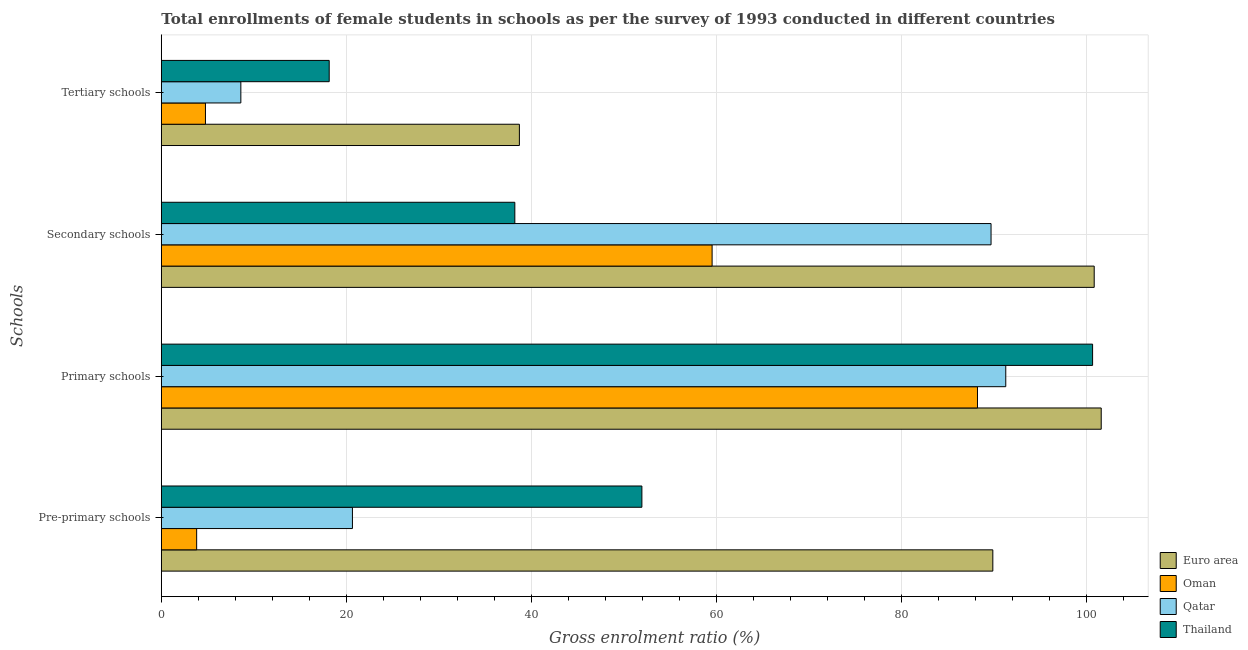Are the number of bars on each tick of the Y-axis equal?
Offer a very short reply. Yes. How many bars are there on the 4th tick from the bottom?
Your answer should be very brief. 4. What is the label of the 4th group of bars from the top?
Make the answer very short. Pre-primary schools. What is the gross enrolment ratio(female) in secondary schools in Oman?
Offer a very short reply. 59.52. Across all countries, what is the maximum gross enrolment ratio(female) in tertiary schools?
Offer a terse response. 38.7. Across all countries, what is the minimum gross enrolment ratio(female) in primary schools?
Your response must be concise. 88.2. In which country was the gross enrolment ratio(female) in pre-primary schools minimum?
Ensure brevity in your answer.  Oman. What is the total gross enrolment ratio(female) in secondary schools in the graph?
Make the answer very short. 288.21. What is the difference between the gross enrolment ratio(female) in tertiary schools in Euro area and that in Oman?
Your response must be concise. 33.93. What is the difference between the gross enrolment ratio(female) in tertiary schools in Thailand and the gross enrolment ratio(female) in secondary schools in Qatar?
Give a very brief answer. -71.52. What is the average gross enrolment ratio(female) in pre-primary schools per country?
Provide a short and direct response. 41.57. What is the difference between the gross enrolment ratio(female) in pre-primary schools and gross enrolment ratio(female) in primary schools in Oman?
Your response must be concise. -84.38. In how many countries, is the gross enrolment ratio(female) in primary schools greater than 76 %?
Offer a terse response. 4. What is the ratio of the gross enrolment ratio(female) in primary schools in Euro area to that in Oman?
Your answer should be compact. 1.15. What is the difference between the highest and the second highest gross enrolment ratio(female) in pre-primary schools?
Make the answer very short. 37.92. What is the difference between the highest and the lowest gross enrolment ratio(female) in secondary schools?
Make the answer very short. 62.61. Is the sum of the gross enrolment ratio(female) in secondary schools in Oman and Euro area greater than the maximum gross enrolment ratio(female) in primary schools across all countries?
Make the answer very short. Yes. Is it the case that in every country, the sum of the gross enrolment ratio(female) in primary schools and gross enrolment ratio(female) in pre-primary schools is greater than the sum of gross enrolment ratio(female) in secondary schools and gross enrolment ratio(female) in tertiary schools?
Provide a succinct answer. No. What does the 2nd bar from the top in Pre-primary schools represents?
Make the answer very short. Qatar. What does the 2nd bar from the bottom in Primary schools represents?
Provide a succinct answer. Oman. Is it the case that in every country, the sum of the gross enrolment ratio(female) in pre-primary schools and gross enrolment ratio(female) in primary schools is greater than the gross enrolment ratio(female) in secondary schools?
Make the answer very short. Yes. Are all the bars in the graph horizontal?
Your answer should be compact. Yes. What is the difference between two consecutive major ticks on the X-axis?
Ensure brevity in your answer.  20. Are the values on the major ticks of X-axis written in scientific E-notation?
Give a very brief answer. No. Where does the legend appear in the graph?
Provide a succinct answer. Bottom right. What is the title of the graph?
Your response must be concise. Total enrollments of female students in schools as per the survey of 1993 conducted in different countries. What is the label or title of the X-axis?
Your response must be concise. Gross enrolment ratio (%). What is the label or title of the Y-axis?
Offer a very short reply. Schools. What is the Gross enrolment ratio (%) in Euro area in Pre-primary schools?
Keep it short and to the point. 89.86. What is the Gross enrolment ratio (%) of Oman in Pre-primary schools?
Your answer should be very brief. 3.82. What is the Gross enrolment ratio (%) of Qatar in Pre-primary schools?
Your answer should be very brief. 20.65. What is the Gross enrolment ratio (%) of Thailand in Pre-primary schools?
Make the answer very short. 51.93. What is the Gross enrolment ratio (%) of Euro area in Primary schools?
Offer a very short reply. 101.57. What is the Gross enrolment ratio (%) of Oman in Primary schools?
Ensure brevity in your answer.  88.2. What is the Gross enrolment ratio (%) in Qatar in Primary schools?
Offer a terse response. 91.26. What is the Gross enrolment ratio (%) of Thailand in Primary schools?
Offer a very short reply. 100.64. What is the Gross enrolment ratio (%) of Euro area in Secondary schools?
Your answer should be very brief. 100.81. What is the Gross enrolment ratio (%) in Oman in Secondary schools?
Your answer should be compact. 59.52. What is the Gross enrolment ratio (%) in Qatar in Secondary schools?
Keep it short and to the point. 89.67. What is the Gross enrolment ratio (%) of Thailand in Secondary schools?
Your answer should be very brief. 38.2. What is the Gross enrolment ratio (%) of Euro area in Tertiary schools?
Keep it short and to the point. 38.7. What is the Gross enrolment ratio (%) in Oman in Tertiary schools?
Keep it short and to the point. 4.77. What is the Gross enrolment ratio (%) of Qatar in Tertiary schools?
Your answer should be very brief. 8.59. What is the Gross enrolment ratio (%) of Thailand in Tertiary schools?
Your answer should be compact. 18.14. Across all Schools, what is the maximum Gross enrolment ratio (%) of Euro area?
Your answer should be very brief. 101.57. Across all Schools, what is the maximum Gross enrolment ratio (%) in Oman?
Your answer should be very brief. 88.2. Across all Schools, what is the maximum Gross enrolment ratio (%) of Qatar?
Offer a very short reply. 91.26. Across all Schools, what is the maximum Gross enrolment ratio (%) in Thailand?
Keep it short and to the point. 100.64. Across all Schools, what is the minimum Gross enrolment ratio (%) of Euro area?
Your answer should be compact. 38.7. Across all Schools, what is the minimum Gross enrolment ratio (%) in Oman?
Make the answer very short. 3.82. Across all Schools, what is the minimum Gross enrolment ratio (%) in Qatar?
Your answer should be very brief. 8.59. Across all Schools, what is the minimum Gross enrolment ratio (%) in Thailand?
Keep it short and to the point. 18.14. What is the total Gross enrolment ratio (%) of Euro area in the graph?
Your answer should be compact. 330.94. What is the total Gross enrolment ratio (%) in Oman in the graph?
Provide a succinct answer. 156.31. What is the total Gross enrolment ratio (%) in Qatar in the graph?
Your answer should be very brief. 210.17. What is the total Gross enrolment ratio (%) of Thailand in the graph?
Provide a succinct answer. 208.92. What is the difference between the Gross enrolment ratio (%) of Euro area in Pre-primary schools and that in Primary schools?
Your response must be concise. -11.71. What is the difference between the Gross enrolment ratio (%) of Oman in Pre-primary schools and that in Primary schools?
Your answer should be very brief. -84.38. What is the difference between the Gross enrolment ratio (%) of Qatar in Pre-primary schools and that in Primary schools?
Your answer should be compact. -70.6. What is the difference between the Gross enrolment ratio (%) of Thailand in Pre-primary schools and that in Primary schools?
Offer a terse response. -48.71. What is the difference between the Gross enrolment ratio (%) in Euro area in Pre-primary schools and that in Secondary schools?
Your response must be concise. -10.96. What is the difference between the Gross enrolment ratio (%) in Oman in Pre-primary schools and that in Secondary schools?
Offer a very short reply. -55.7. What is the difference between the Gross enrolment ratio (%) in Qatar in Pre-primary schools and that in Secondary schools?
Give a very brief answer. -69.01. What is the difference between the Gross enrolment ratio (%) in Thailand in Pre-primary schools and that in Secondary schools?
Offer a terse response. 13.73. What is the difference between the Gross enrolment ratio (%) in Euro area in Pre-primary schools and that in Tertiary schools?
Provide a succinct answer. 51.16. What is the difference between the Gross enrolment ratio (%) of Oman in Pre-primary schools and that in Tertiary schools?
Keep it short and to the point. -0.95. What is the difference between the Gross enrolment ratio (%) of Qatar in Pre-primary schools and that in Tertiary schools?
Your answer should be compact. 12.06. What is the difference between the Gross enrolment ratio (%) in Thailand in Pre-primary schools and that in Tertiary schools?
Ensure brevity in your answer.  33.79. What is the difference between the Gross enrolment ratio (%) in Euro area in Primary schools and that in Secondary schools?
Your answer should be compact. 0.76. What is the difference between the Gross enrolment ratio (%) of Oman in Primary schools and that in Secondary schools?
Offer a terse response. 28.68. What is the difference between the Gross enrolment ratio (%) of Qatar in Primary schools and that in Secondary schools?
Keep it short and to the point. 1.59. What is the difference between the Gross enrolment ratio (%) in Thailand in Primary schools and that in Secondary schools?
Offer a very short reply. 62.44. What is the difference between the Gross enrolment ratio (%) of Euro area in Primary schools and that in Tertiary schools?
Ensure brevity in your answer.  62.88. What is the difference between the Gross enrolment ratio (%) of Oman in Primary schools and that in Tertiary schools?
Your response must be concise. 83.43. What is the difference between the Gross enrolment ratio (%) of Qatar in Primary schools and that in Tertiary schools?
Your answer should be compact. 82.66. What is the difference between the Gross enrolment ratio (%) of Thailand in Primary schools and that in Tertiary schools?
Keep it short and to the point. 82.5. What is the difference between the Gross enrolment ratio (%) of Euro area in Secondary schools and that in Tertiary schools?
Give a very brief answer. 62.12. What is the difference between the Gross enrolment ratio (%) in Oman in Secondary schools and that in Tertiary schools?
Your response must be concise. 54.75. What is the difference between the Gross enrolment ratio (%) of Qatar in Secondary schools and that in Tertiary schools?
Make the answer very short. 81.07. What is the difference between the Gross enrolment ratio (%) of Thailand in Secondary schools and that in Tertiary schools?
Keep it short and to the point. 20.06. What is the difference between the Gross enrolment ratio (%) of Euro area in Pre-primary schools and the Gross enrolment ratio (%) of Oman in Primary schools?
Your response must be concise. 1.66. What is the difference between the Gross enrolment ratio (%) of Euro area in Pre-primary schools and the Gross enrolment ratio (%) of Qatar in Primary schools?
Make the answer very short. -1.4. What is the difference between the Gross enrolment ratio (%) in Euro area in Pre-primary schools and the Gross enrolment ratio (%) in Thailand in Primary schools?
Give a very brief answer. -10.78. What is the difference between the Gross enrolment ratio (%) in Oman in Pre-primary schools and the Gross enrolment ratio (%) in Qatar in Primary schools?
Your answer should be compact. -87.44. What is the difference between the Gross enrolment ratio (%) of Oman in Pre-primary schools and the Gross enrolment ratio (%) of Thailand in Primary schools?
Your answer should be compact. -96.82. What is the difference between the Gross enrolment ratio (%) in Qatar in Pre-primary schools and the Gross enrolment ratio (%) in Thailand in Primary schools?
Provide a short and direct response. -79.99. What is the difference between the Gross enrolment ratio (%) of Euro area in Pre-primary schools and the Gross enrolment ratio (%) of Oman in Secondary schools?
Offer a very short reply. 30.34. What is the difference between the Gross enrolment ratio (%) of Euro area in Pre-primary schools and the Gross enrolment ratio (%) of Qatar in Secondary schools?
Keep it short and to the point. 0.19. What is the difference between the Gross enrolment ratio (%) of Euro area in Pre-primary schools and the Gross enrolment ratio (%) of Thailand in Secondary schools?
Keep it short and to the point. 51.66. What is the difference between the Gross enrolment ratio (%) in Oman in Pre-primary schools and the Gross enrolment ratio (%) in Qatar in Secondary schools?
Provide a short and direct response. -85.85. What is the difference between the Gross enrolment ratio (%) of Oman in Pre-primary schools and the Gross enrolment ratio (%) of Thailand in Secondary schools?
Keep it short and to the point. -34.38. What is the difference between the Gross enrolment ratio (%) in Qatar in Pre-primary schools and the Gross enrolment ratio (%) in Thailand in Secondary schools?
Give a very brief answer. -17.55. What is the difference between the Gross enrolment ratio (%) in Euro area in Pre-primary schools and the Gross enrolment ratio (%) in Oman in Tertiary schools?
Provide a short and direct response. 85.09. What is the difference between the Gross enrolment ratio (%) of Euro area in Pre-primary schools and the Gross enrolment ratio (%) of Qatar in Tertiary schools?
Provide a short and direct response. 81.26. What is the difference between the Gross enrolment ratio (%) in Euro area in Pre-primary schools and the Gross enrolment ratio (%) in Thailand in Tertiary schools?
Your response must be concise. 71.71. What is the difference between the Gross enrolment ratio (%) in Oman in Pre-primary schools and the Gross enrolment ratio (%) in Qatar in Tertiary schools?
Offer a very short reply. -4.77. What is the difference between the Gross enrolment ratio (%) in Oman in Pre-primary schools and the Gross enrolment ratio (%) in Thailand in Tertiary schools?
Your response must be concise. -14.32. What is the difference between the Gross enrolment ratio (%) of Qatar in Pre-primary schools and the Gross enrolment ratio (%) of Thailand in Tertiary schools?
Make the answer very short. 2.51. What is the difference between the Gross enrolment ratio (%) of Euro area in Primary schools and the Gross enrolment ratio (%) of Oman in Secondary schools?
Your answer should be very brief. 42.05. What is the difference between the Gross enrolment ratio (%) of Euro area in Primary schools and the Gross enrolment ratio (%) of Qatar in Secondary schools?
Provide a succinct answer. 11.91. What is the difference between the Gross enrolment ratio (%) in Euro area in Primary schools and the Gross enrolment ratio (%) in Thailand in Secondary schools?
Offer a very short reply. 63.37. What is the difference between the Gross enrolment ratio (%) of Oman in Primary schools and the Gross enrolment ratio (%) of Qatar in Secondary schools?
Give a very brief answer. -1.46. What is the difference between the Gross enrolment ratio (%) in Oman in Primary schools and the Gross enrolment ratio (%) in Thailand in Secondary schools?
Offer a terse response. 50. What is the difference between the Gross enrolment ratio (%) of Qatar in Primary schools and the Gross enrolment ratio (%) of Thailand in Secondary schools?
Offer a terse response. 53.05. What is the difference between the Gross enrolment ratio (%) in Euro area in Primary schools and the Gross enrolment ratio (%) in Oman in Tertiary schools?
Give a very brief answer. 96.8. What is the difference between the Gross enrolment ratio (%) of Euro area in Primary schools and the Gross enrolment ratio (%) of Qatar in Tertiary schools?
Offer a terse response. 92.98. What is the difference between the Gross enrolment ratio (%) of Euro area in Primary schools and the Gross enrolment ratio (%) of Thailand in Tertiary schools?
Ensure brevity in your answer.  83.43. What is the difference between the Gross enrolment ratio (%) of Oman in Primary schools and the Gross enrolment ratio (%) of Qatar in Tertiary schools?
Provide a succinct answer. 79.61. What is the difference between the Gross enrolment ratio (%) in Oman in Primary schools and the Gross enrolment ratio (%) in Thailand in Tertiary schools?
Your response must be concise. 70.06. What is the difference between the Gross enrolment ratio (%) of Qatar in Primary schools and the Gross enrolment ratio (%) of Thailand in Tertiary schools?
Provide a short and direct response. 73.11. What is the difference between the Gross enrolment ratio (%) in Euro area in Secondary schools and the Gross enrolment ratio (%) in Oman in Tertiary schools?
Offer a terse response. 96.05. What is the difference between the Gross enrolment ratio (%) of Euro area in Secondary schools and the Gross enrolment ratio (%) of Qatar in Tertiary schools?
Provide a short and direct response. 92.22. What is the difference between the Gross enrolment ratio (%) in Euro area in Secondary schools and the Gross enrolment ratio (%) in Thailand in Tertiary schools?
Ensure brevity in your answer.  82.67. What is the difference between the Gross enrolment ratio (%) of Oman in Secondary schools and the Gross enrolment ratio (%) of Qatar in Tertiary schools?
Your answer should be very brief. 50.93. What is the difference between the Gross enrolment ratio (%) in Oman in Secondary schools and the Gross enrolment ratio (%) in Thailand in Tertiary schools?
Your response must be concise. 41.38. What is the difference between the Gross enrolment ratio (%) of Qatar in Secondary schools and the Gross enrolment ratio (%) of Thailand in Tertiary schools?
Make the answer very short. 71.52. What is the average Gross enrolment ratio (%) in Euro area per Schools?
Your answer should be very brief. 82.74. What is the average Gross enrolment ratio (%) in Oman per Schools?
Keep it short and to the point. 39.08. What is the average Gross enrolment ratio (%) in Qatar per Schools?
Provide a short and direct response. 52.54. What is the average Gross enrolment ratio (%) in Thailand per Schools?
Offer a very short reply. 52.23. What is the difference between the Gross enrolment ratio (%) of Euro area and Gross enrolment ratio (%) of Oman in Pre-primary schools?
Provide a short and direct response. 86.04. What is the difference between the Gross enrolment ratio (%) of Euro area and Gross enrolment ratio (%) of Qatar in Pre-primary schools?
Offer a very short reply. 69.2. What is the difference between the Gross enrolment ratio (%) in Euro area and Gross enrolment ratio (%) in Thailand in Pre-primary schools?
Ensure brevity in your answer.  37.92. What is the difference between the Gross enrolment ratio (%) of Oman and Gross enrolment ratio (%) of Qatar in Pre-primary schools?
Offer a terse response. -16.83. What is the difference between the Gross enrolment ratio (%) of Oman and Gross enrolment ratio (%) of Thailand in Pre-primary schools?
Give a very brief answer. -48.11. What is the difference between the Gross enrolment ratio (%) of Qatar and Gross enrolment ratio (%) of Thailand in Pre-primary schools?
Provide a succinct answer. -31.28. What is the difference between the Gross enrolment ratio (%) of Euro area and Gross enrolment ratio (%) of Oman in Primary schools?
Your response must be concise. 13.37. What is the difference between the Gross enrolment ratio (%) in Euro area and Gross enrolment ratio (%) in Qatar in Primary schools?
Offer a very short reply. 10.31. What is the difference between the Gross enrolment ratio (%) in Euro area and Gross enrolment ratio (%) in Thailand in Primary schools?
Keep it short and to the point. 0.93. What is the difference between the Gross enrolment ratio (%) in Oman and Gross enrolment ratio (%) in Qatar in Primary schools?
Provide a succinct answer. -3.06. What is the difference between the Gross enrolment ratio (%) in Oman and Gross enrolment ratio (%) in Thailand in Primary schools?
Your answer should be compact. -12.44. What is the difference between the Gross enrolment ratio (%) in Qatar and Gross enrolment ratio (%) in Thailand in Primary schools?
Make the answer very short. -9.38. What is the difference between the Gross enrolment ratio (%) in Euro area and Gross enrolment ratio (%) in Oman in Secondary schools?
Keep it short and to the point. 41.29. What is the difference between the Gross enrolment ratio (%) of Euro area and Gross enrolment ratio (%) of Qatar in Secondary schools?
Ensure brevity in your answer.  11.15. What is the difference between the Gross enrolment ratio (%) of Euro area and Gross enrolment ratio (%) of Thailand in Secondary schools?
Offer a very short reply. 62.61. What is the difference between the Gross enrolment ratio (%) of Oman and Gross enrolment ratio (%) of Qatar in Secondary schools?
Offer a very short reply. -30.14. What is the difference between the Gross enrolment ratio (%) in Oman and Gross enrolment ratio (%) in Thailand in Secondary schools?
Ensure brevity in your answer.  21.32. What is the difference between the Gross enrolment ratio (%) in Qatar and Gross enrolment ratio (%) in Thailand in Secondary schools?
Offer a very short reply. 51.46. What is the difference between the Gross enrolment ratio (%) of Euro area and Gross enrolment ratio (%) of Oman in Tertiary schools?
Provide a succinct answer. 33.93. What is the difference between the Gross enrolment ratio (%) in Euro area and Gross enrolment ratio (%) in Qatar in Tertiary schools?
Offer a very short reply. 30.1. What is the difference between the Gross enrolment ratio (%) of Euro area and Gross enrolment ratio (%) of Thailand in Tertiary schools?
Your answer should be compact. 20.55. What is the difference between the Gross enrolment ratio (%) in Oman and Gross enrolment ratio (%) in Qatar in Tertiary schools?
Offer a terse response. -3.83. What is the difference between the Gross enrolment ratio (%) of Oman and Gross enrolment ratio (%) of Thailand in Tertiary schools?
Offer a terse response. -13.37. What is the difference between the Gross enrolment ratio (%) of Qatar and Gross enrolment ratio (%) of Thailand in Tertiary schools?
Your answer should be compact. -9.55. What is the ratio of the Gross enrolment ratio (%) in Euro area in Pre-primary schools to that in Primary schools?
Give a very brief answer. 0.88. What is the ratio of the Gross enrolment ratio (%) of Oman in Pre-primary schools to that in Primary schools?
Ensure brevity in your answer.  0.04. What is the ratio of the Gross enrolment ratio (%) of Qatar in Pre-primary schools to that in Primary schools?
Your answer should be compact. 0.23. What is the ratio of the Gross enrolment ratio (%) in Thailand in Pre-primary schools to that in Primary schools?
Your answer should be very brief. 0.52. What is the ratio of the Gross enrolment ratio (%) in Euro area in Pre-primary schools to that in Secondary schools?
Your response must be concise. 0.89. What is the ratio of the Gross enrolment ratio (%) of Oman in Pre-primary schools to that in Secondary schools?
Your answer should be very brief. 0.06. What is the ratio of the Gross enrolment ratio (%) of Qatar in Pre-primary schools to that in Secondary schools?
Offer a very short reply. 0.23. What is the ratio of the Gross enrolment ratio (%) in Thailand in Pre-primary schools to that in Secondary schools?
Your answer should be compact. 1.36. What is the ratio of the Gross enrolment ratio (%) in Euro area in Pre-primary schools to that in Tertiary schools?
Ensure brevity in your answer.  2.32. What is the ratio of the Gross enrolment ratio (%) in Oman in Pre-primary schools to that in Tertiary schools?
Ensure brevity in your answer.  0.8. What is the ratio of the Gross enrolment ratio (%) of Qatar in Pre-primary schools to that in Tertiary schools?
Provide a short and direct response. 2.4. What is the ratio of the Gross enrolment ratio (%) of Thailand in Pre-primary schools to that in Tertiary schools?
Give a very brief answer. 2.86. What is the ratio of the Gross enrolment ratio (%) in Euro area in Primary schools to that in Secondary schools?
Ensure brevity in your answer.  1.01. What is the ratio of the Gross enrolment ratio (%) of Oman in Primary schools to that in Secondary schools?
Make the answer very short. 1.48. What is the ratio of the Gross enrolment ratio (%) in Qatar in Primary schools to that in Secondary schools?
Your response must be concise. 1.02. What is the ratio of the Gross enrolment ratio (%) of Thailand in Primary schools to that in Secondary schools?
Provide a short and direct response. 2.63. What is the ratio of the Gross enrolment ratio (%) of Euro area in Primary schools to that in Tertiary schools?
Your answer should be compact. 2.62. What is the ratio of the Gross enrolment ratio (%) of Oman in Primary schools to that in Tertiary schools?
Make the answer very short. 18.49. What is the ratio of the Gross enrolment ratio (%) of Qatar in Primary schools to that in Tertiary schools?
Offer a very short reply. 10.62. What is the ratio of the Gross enrolment ratio (%) of Thailand in Primary schools to that in Tertiary schools?
Make the answer very short. 5.55. What is the ratio of the Gross enrolment ratio (%) of Euro area in Secondary schools to that in Tertiary schools?
Give a very brief answer. 2.61. What is the ratio of the Gross enrolment ratio (%) in Oman in Secondary schools to that in Tertiary schools?
Ensure brevity in your answer.  12.48. What is the ratio of the Gross enrolment ratio (%) of Qatar in Secondary schools to that in Tertiary schools?
Offer a very short reply. 10.43. What is the ratio of the Gross enrolment ratio (%) of Thailand in Secondary schools to that in Tertiary schools?
Make the answer very short. 2.11. What is the difference between the highest and the second highest Gross enrolment ratio (%) in Euro area?
Keep it short and to the point. 0.76. What is the difference between the highest and the second highest Gross enrolment ratio (%) in Oman?
Your answer should be compact. 28.68. What is the difference between the highest and the second highest Gross enrolment ratio (%) of Qatar?
Your answer should be very brief. 1.59. What is the difference between the highest and the second highest Gross enrolment ratio (%) in Thailand?
Offer a terse response. 48.71. What is the difference between the highest and the lowest Gross enrolment ratio (%) of Euro area?
Your answer should be compact. 62.88. What is the difference between the highest and the lowest Gross enrolment ratio (%) in Oman?
Offer a terse response. 84.38. What is the difference between the highest and the lowest Gross enrolment ratio (%) in Qatar?
Your response must be concise. 82.66. What is the difference between the highest and the lowest Gross enrolment ratio (%) of Thailand?
Ensure brevity in your answer.  82.5. 